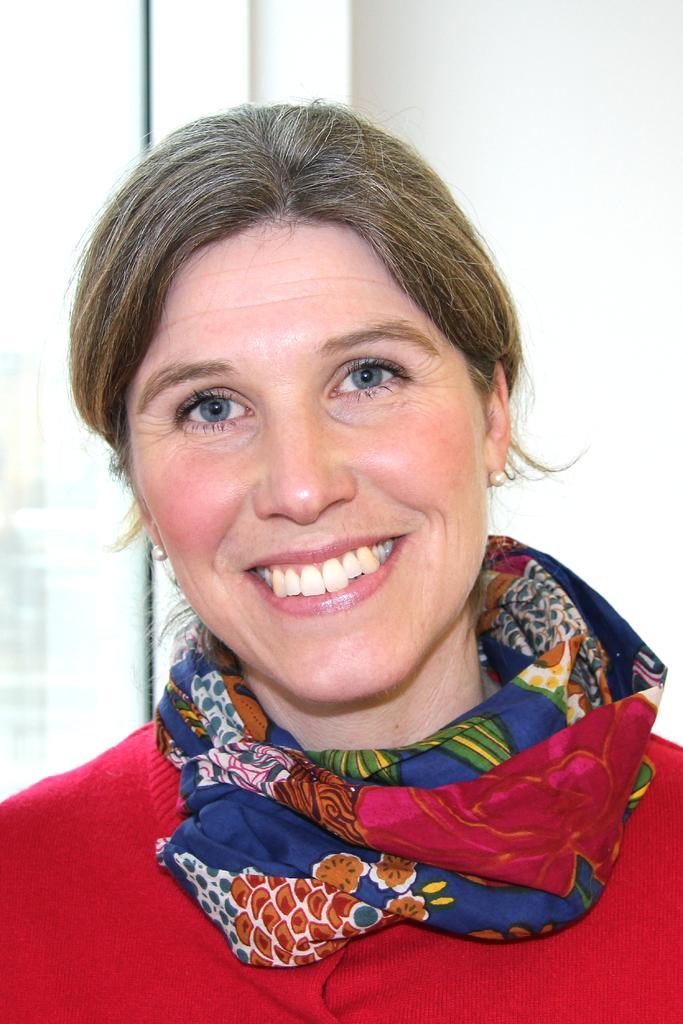Please provide a concise description of this image. A woman is smiling, she wore red color dress. 